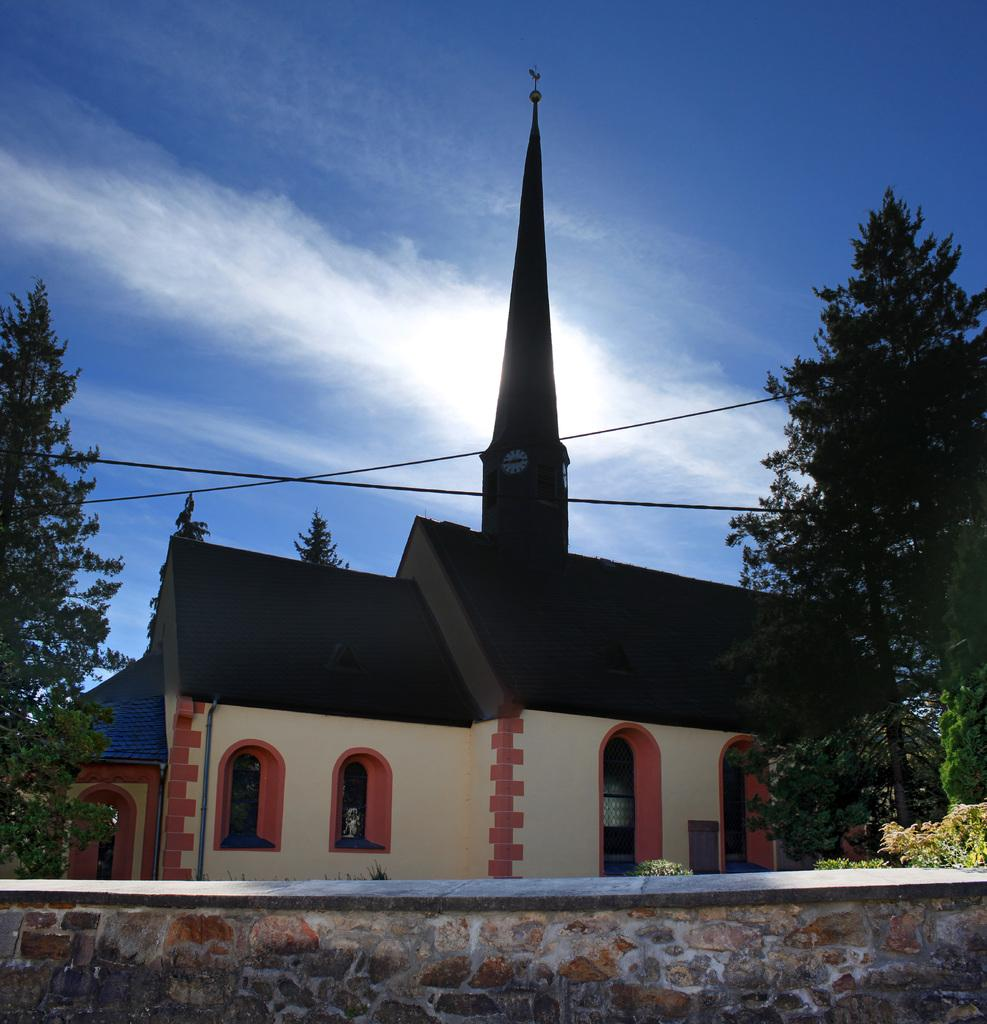What is attached to the building in the image? There is a clock attached to the building. What can be seen in front of the building? There are trees and a wall in front of the building. What object is present in front of the wall? There is a rope in front of the wall. What is visible in the background of the image? The sky is visible in the image. How does the air affect the movement of the worm in the image? There is no worm present in the image, so the air's effect on its movement cannot be determined. 